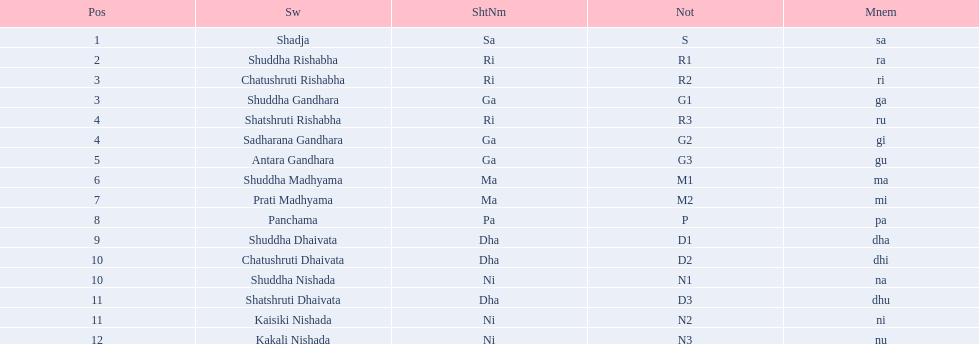What is the name of the swara that comes after panchama? Shuddha Dhaivata. 